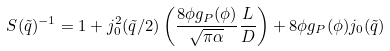<formula> <loc_0><loc_0><loc_500><loc_500>S ( \tilde { q } ) ^ { - 1 } = 1 + j _ { 0 } ^ { 2 } ( \tilde { q } / 2 ) \left ( \frac { 8 \phi g _ { P } ( \phi ) } { \sqrt { \pi \alpha } } \frac { L } { D } \right ) + 8 \phi g _ { P } ( \phi ) j _ { 0 } ( \tilde { q } )</formula> 